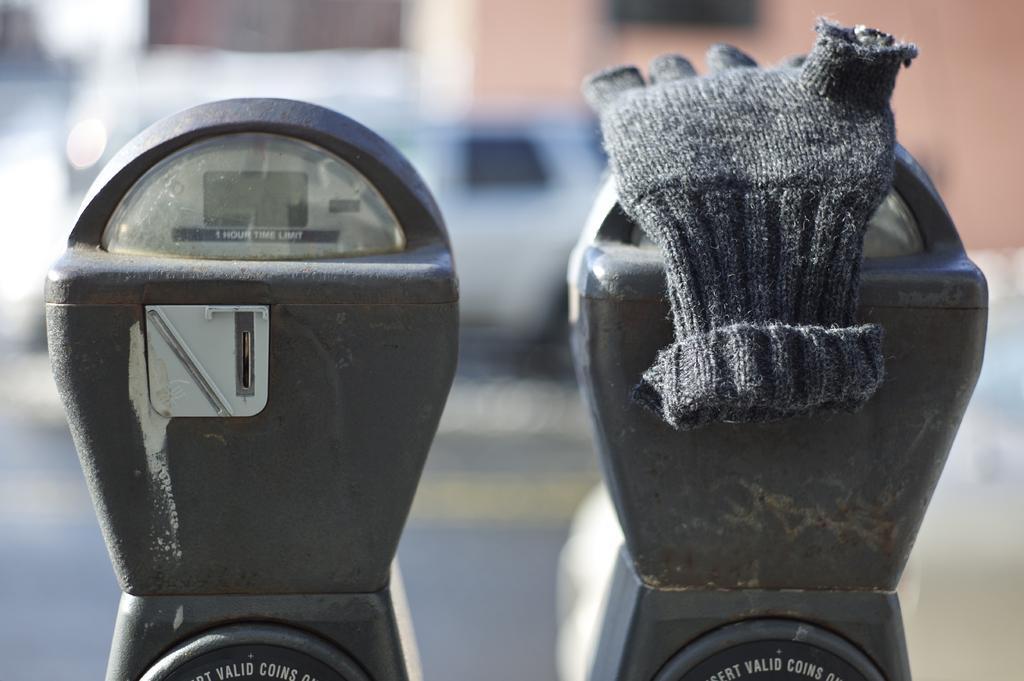Can you describe this image briefly? Here we can see parking meters. On this parking meter there is a gloves. Background it is blurry and we can see a vehicle. 